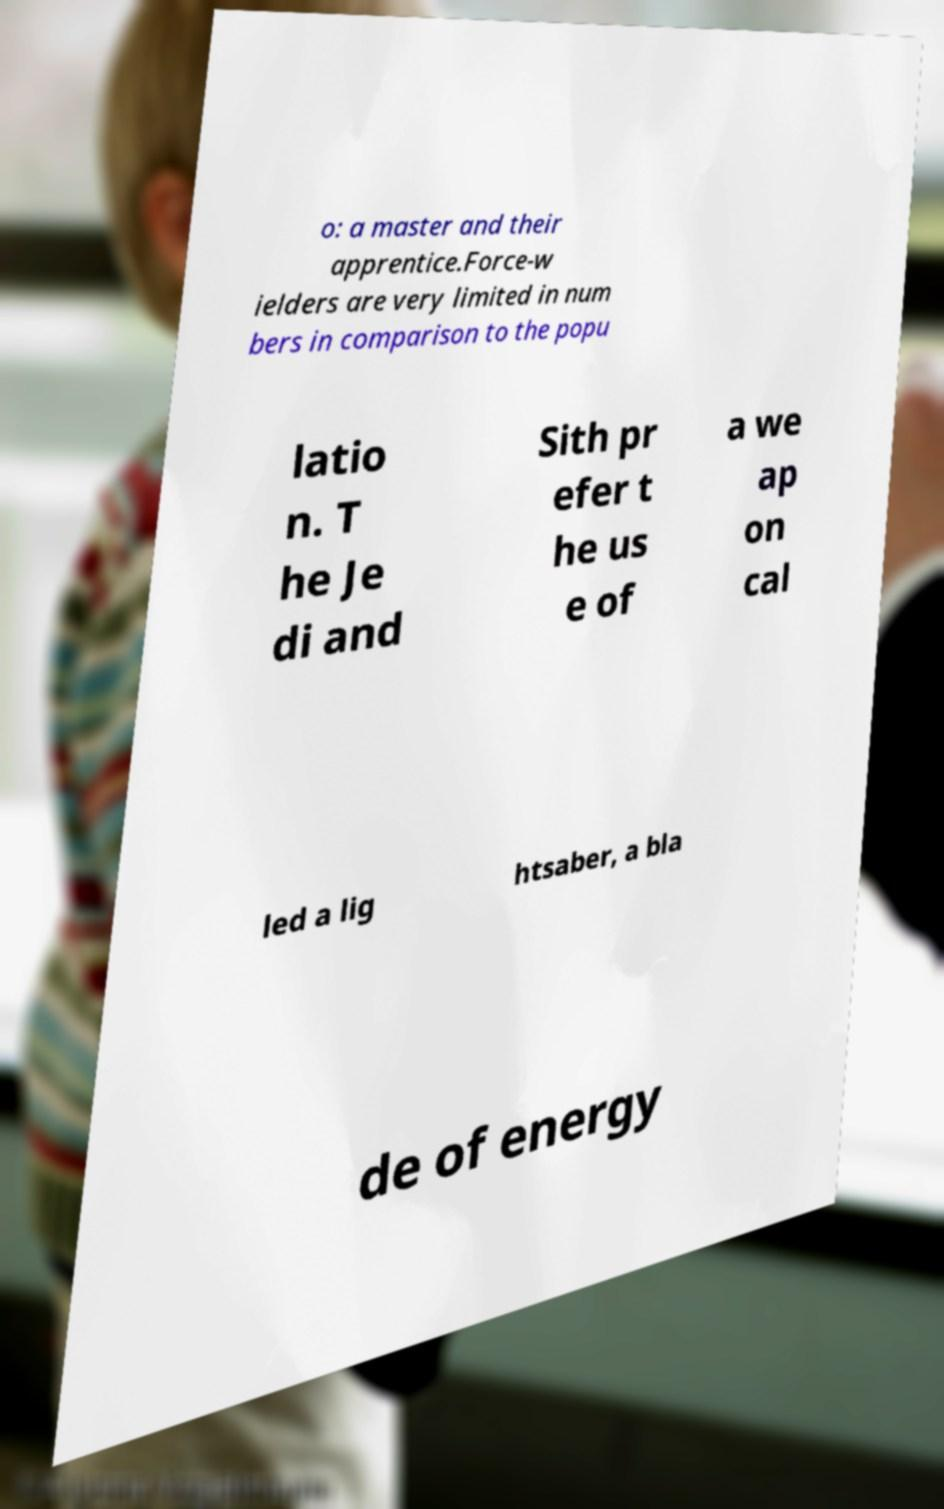Please read and relay the text visible in this image. What does it say? o: a master and their apprentice.Force-w ielders are very limited in num bers in comparison to the popu latio n. T he Je di and Sith pr efer t he us e of a we ap on cal led a lig htsaber, a bla de of energy 